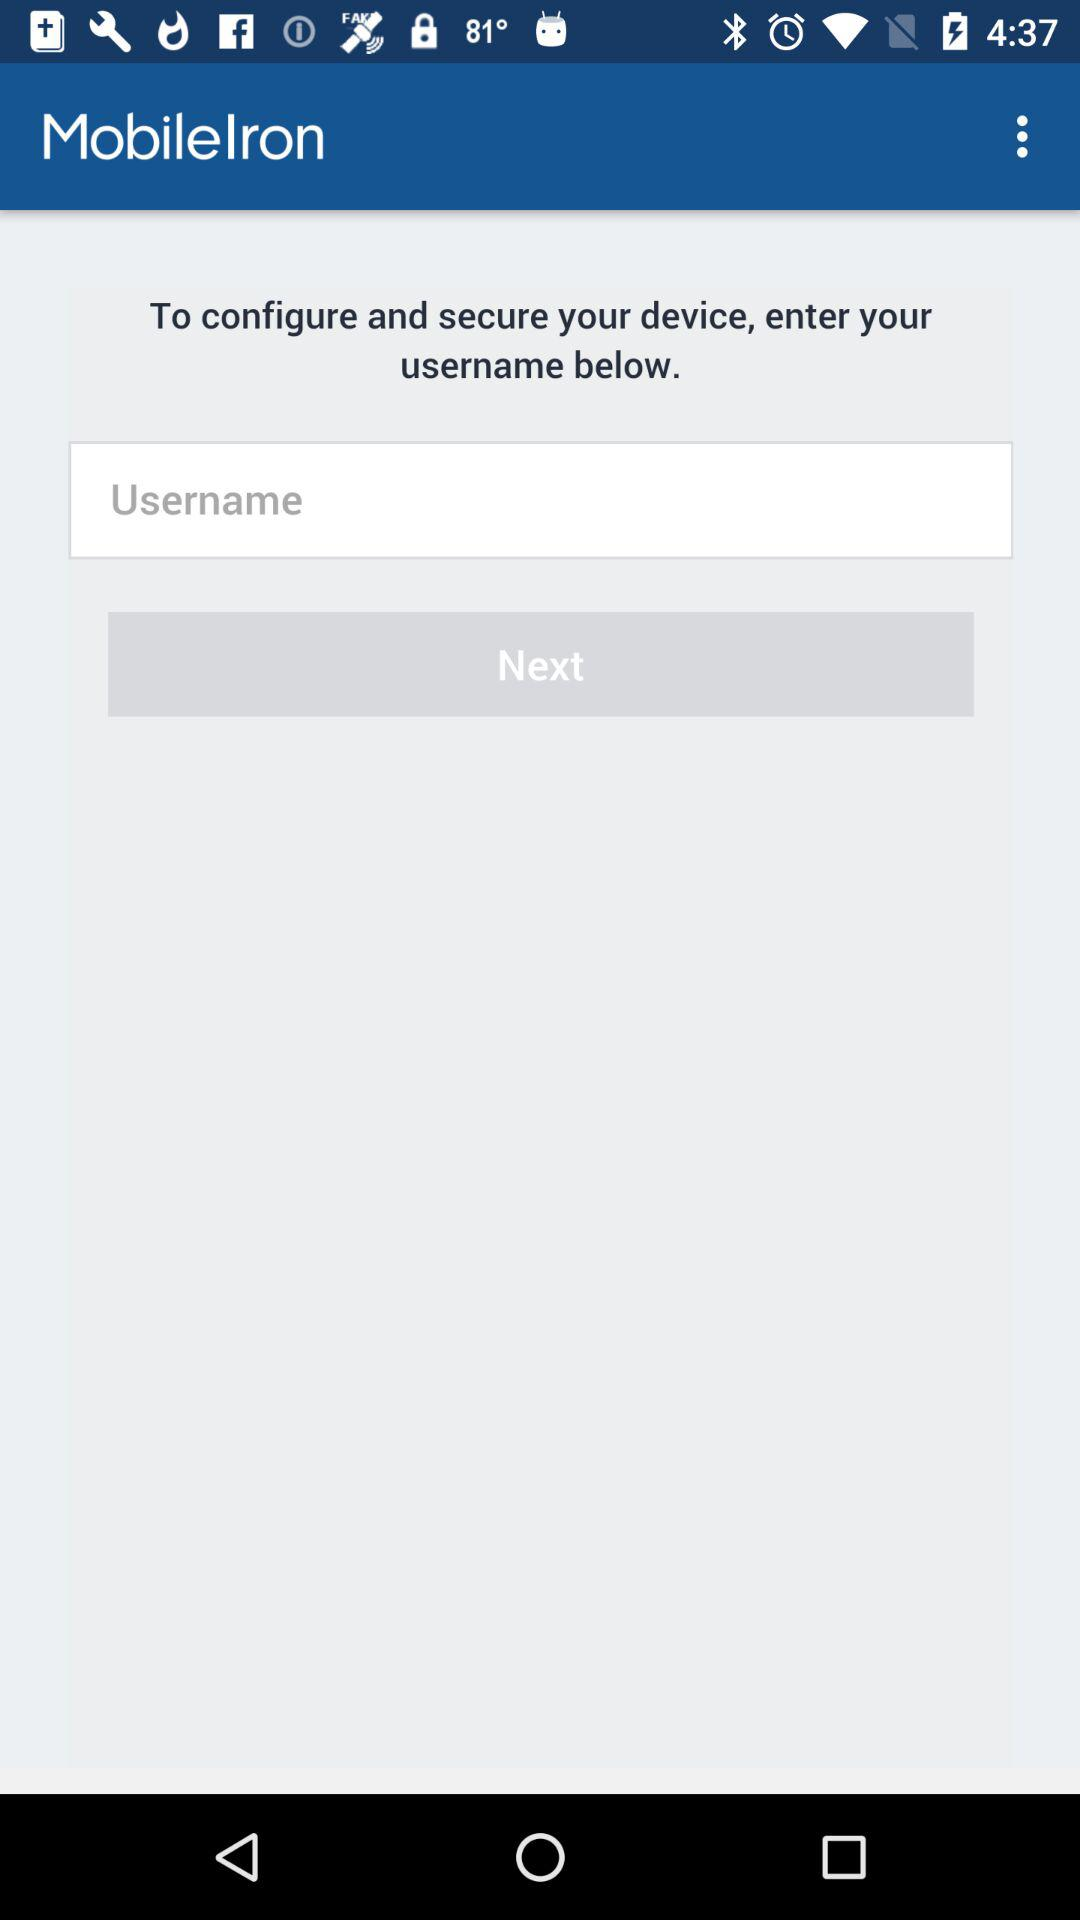What is the entered username?
When the provided information is insufficient, respond with <no answer>. <no answer> 